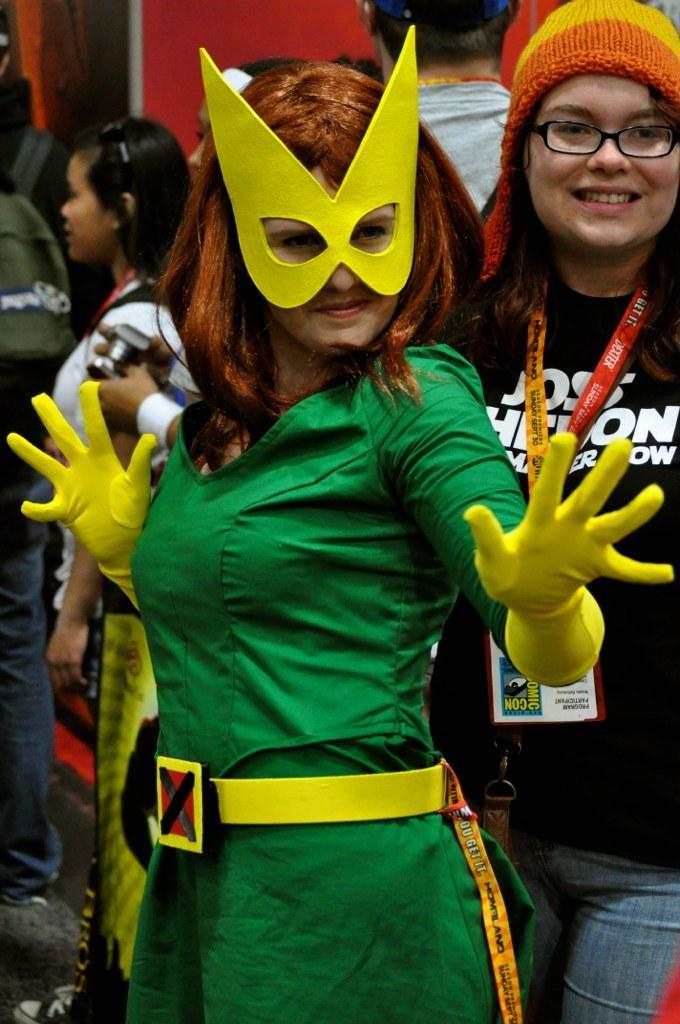What is the lady in the foreground of the image wearing? The lady in the foreground of the image is wearing a costume. Can you describe the lady in the background of the image? The lady in the background of the image is wearing a tag, glasses, and a cap. How many people are present in the image? There are people present in the image, but the exact number is not specified. What type of plants can be seen growing in the air in the image? There is no mention of plants or air in the image, so it cannot be determined if any plants are growing in the air. 